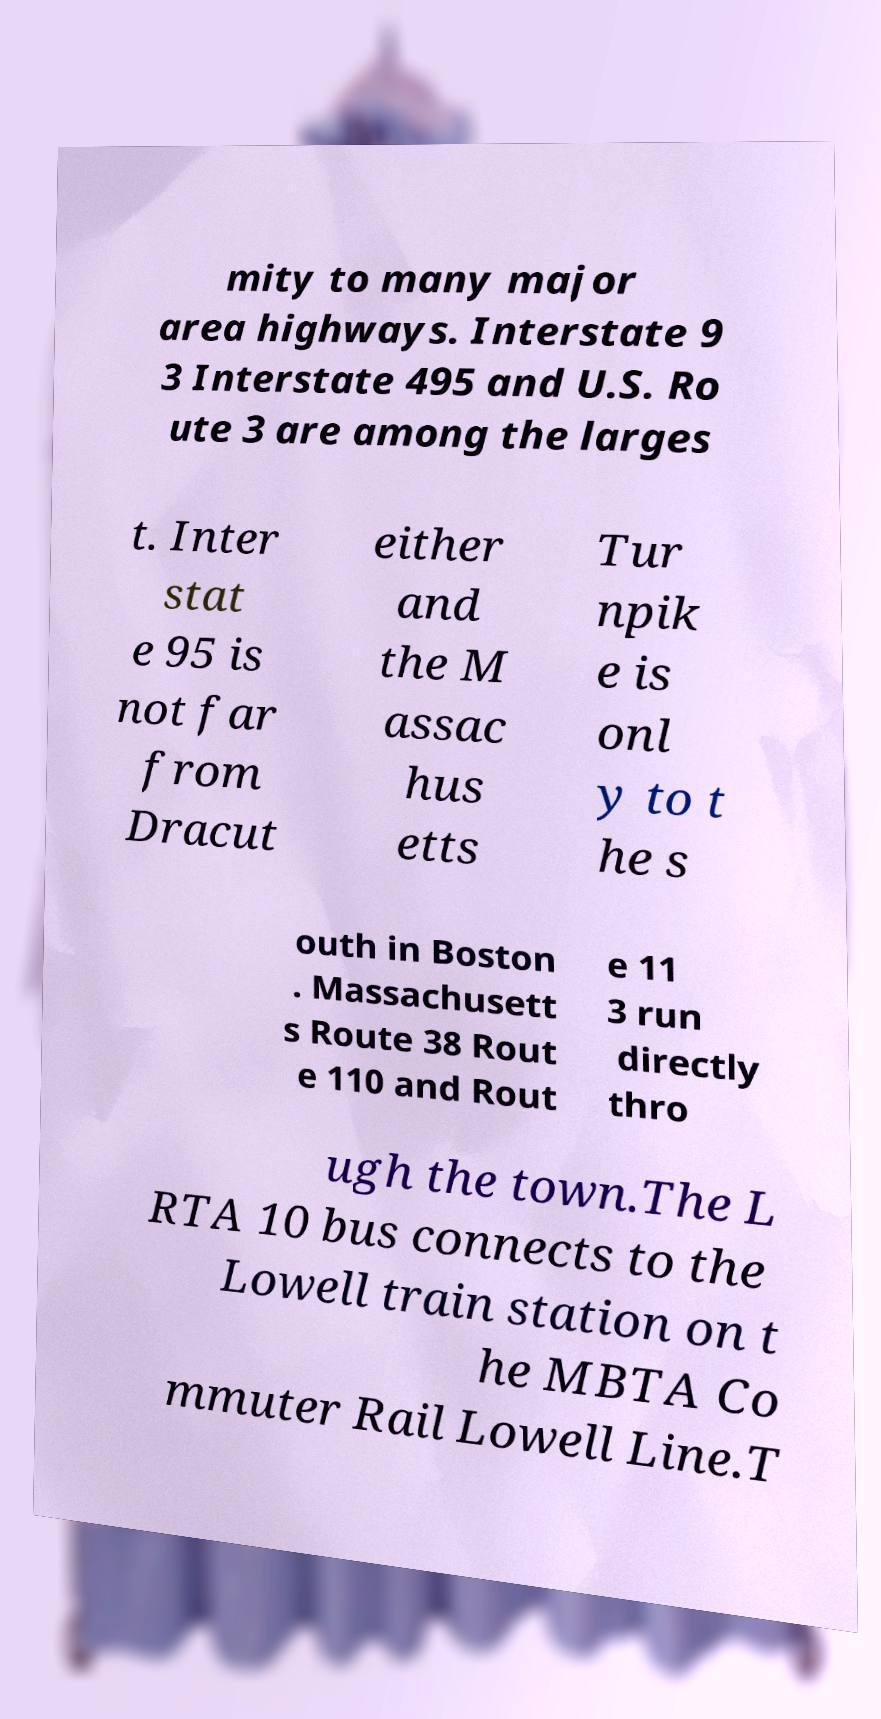Please read and relay the text visible in this image. What does it say? mity to many major area highways. Interstate 9 3 Interstate 495 and U.S. Ro ute 3 are among the larges t. Inter stat e 95 is not far from Dracut either and the M assac hus etts Tur npik e is onl y to t he s outh in Boston . Massachusett s Route 38 Rout e 110 and Rout e 11 3 run directly thro ugh the town.The L RTA 10 bus connects to the Lowell train station on t he MBTA Co mmuter Rail Lowell Line.T 